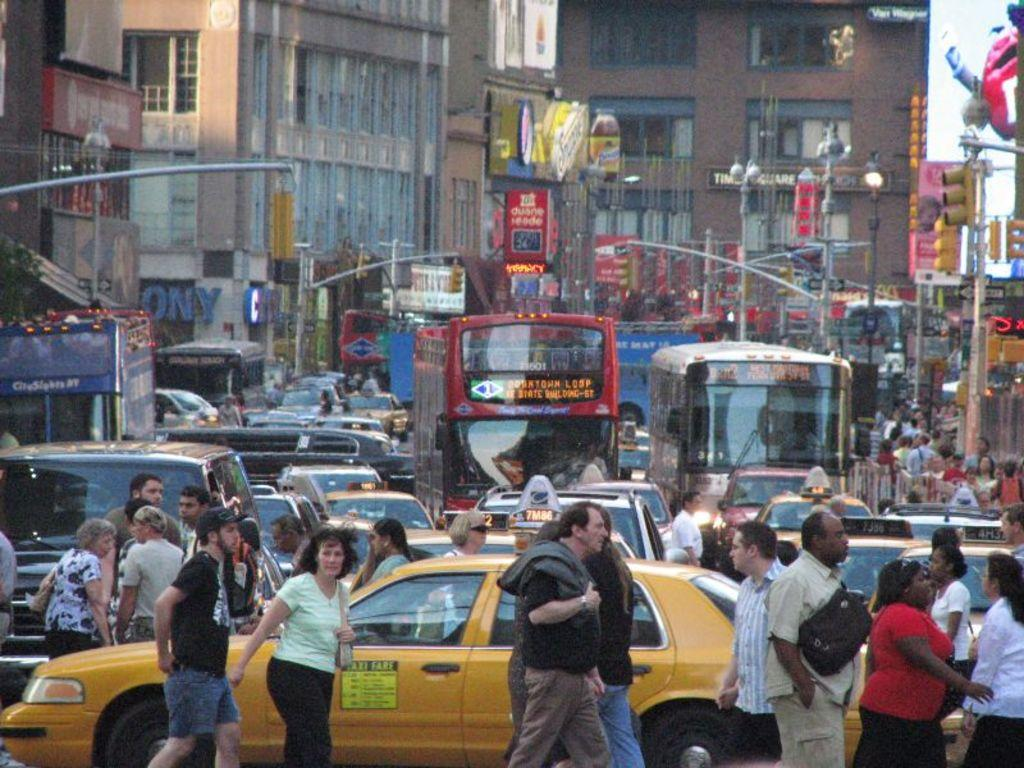<image>
Relay a brief, clear account of the picture shown. In a busy street, the yellow cab has a sign on the side of the door explaining the fare prices. 